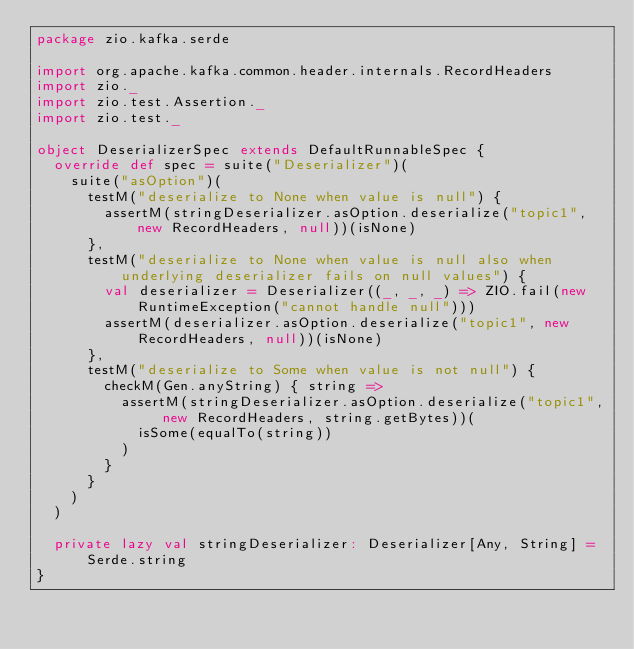<code> <loc_0><loc_0><loc_500><loc_500><_Scala_>package zio.kafka.serde

import org.apache.kafka.common.header.internals.RecordHeaders
import zio._
import zio.test.Assertion._
import zio.test._

object DeserializerSpec extends DefaultRunnableSpec {
  override def spec = suite("Deserializer")(
    suite("asOption")(
      testM("deserialize to None when value is null") {
        assertM(stringDeserializer.asOption.deserialize("topic1", new RecordHeaders, null))(isNone)
      },
      testM("deserialize to None when value is null also when underlying deserializer fails on null values") {
        val deserializer = Deserializer((_, _, _) => ZIO.fail(new RuntimeException("cannot handle null")))
        assertM(deserializer.asOption.deserialize("topic1", new RecordHeaders, null))(isNone)
      },
      testM("deserialize to Some when value is not null") {
        checkM(Gen.anyString) { string =>
          assertM(stringDeserializer.asOption.deserialize("topic1", new RecordHeaders, string.getBytes))(
            isSome(equalTo(string))
          )
        }
      }
    )
  )

  private lazy val stringDeserializer: Deserializer[Any, String] = Serde.string
}
</code> 